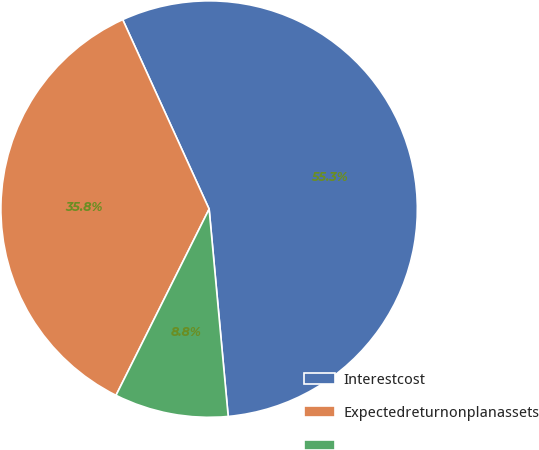<chart> <loc_0><loc_0><loc_500><loc_500><pie_chart><fcel>Interestcost<fcel>Expectedreturnonplanassets<fcel>Unnamed: 2<nl><fcel>55.35%<fcel>35.81%<fcel>8.84%<nl></chart> 